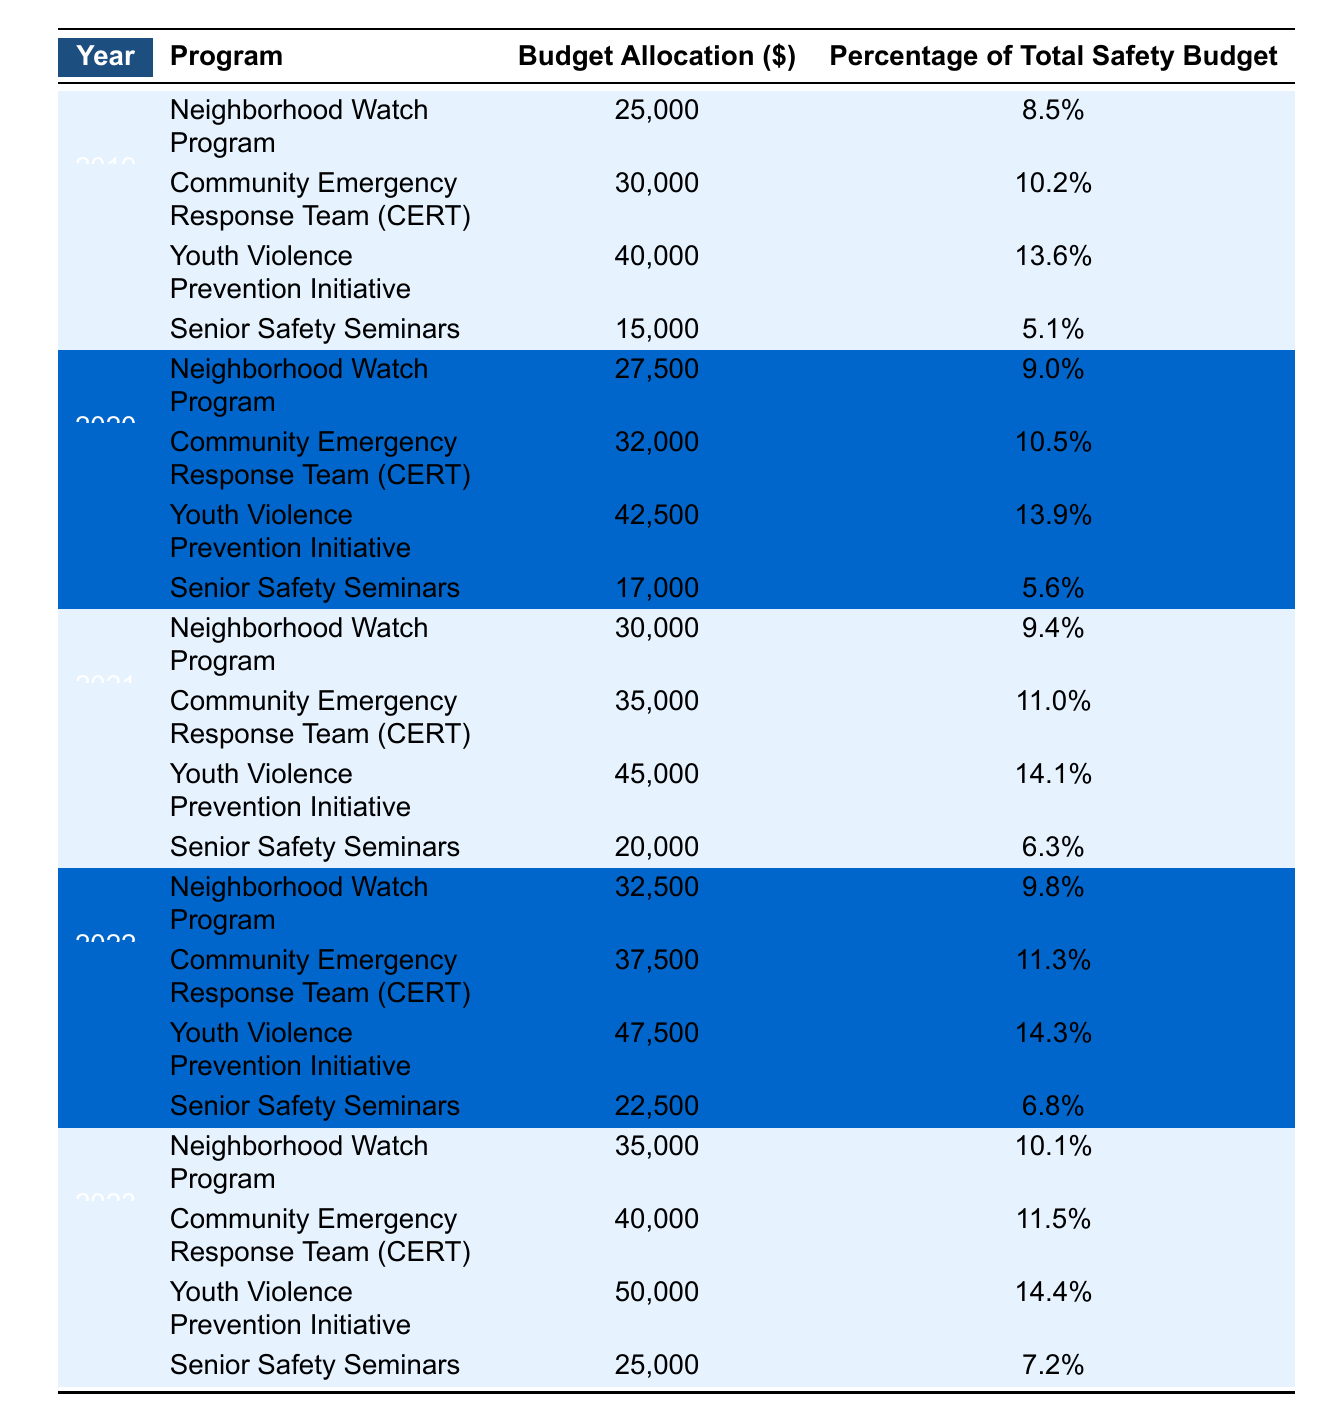What was the budget allocation for the Youth Violence Prevention Initiative in 2021? In the table, under the year 2021, the Youth Violence Prevention Initiative has a budget allocation of $45,000.
Answer: $45,000 What percentage of the total safety budget was allocated to the Senior Safety Seminars in 2022? The table shows that in 2022, the Senior Safety Seminars received a budget allocation of $22,500, which corresponds to 6.8% of the total safety budget.
Answer: 6.8% Which program saw the highest budget allocation in 2023? Looking at the 2023 row of the table, the Youth Violence Prevention Initiative had the highest budget allocation at $50,000.
Answer: Youth Violence Prevention Initiative What was the average budget allocation for the Neighborhood Watch Program from 2019 to 2023? To find the average, sum the budget allocations for the Neighborhood Watch Program: $25,000 + $27,500 + $30,000 + $32,500 + $35,000 = $150,000. Then divide by the 5 years: $150,000 / 5 = $30,000.
Answer: $30,000 Which program had the lowest budget allocation in 2019 and is it still the lowest in 2023? In 2019, the program with the lowest budget allocation was the Senior Safety Seminars with $15,000. In 2023, the Senior Safety Seminars had a budget of $25,000, which is still the lowest compared to the other programs for that year.
Answer: Yes What is the total budget allocated to the Community Emergency Response Team (CERT) from 2019 to 2023? Summing the allocations for CERT from the table: $30,000 (2019) + $32,000 (2020) + $35,000 (2021) + $37,500 (2022) + $40,000 (2023) gives a total of $174,500.
Answer: $174,500 Did the budget allocation for the Senior Safety Seminars increase from 2019 to 2023? In 2019, the allocation was $15,000, and in 2023, it increased to $25,000, indicating a rise in budget allocation over the years.
Answer: Yes What will be the total budget allocation for all programs in 2020? By adding all program allocations for 2020: $27,500 (Neighborhood Watch) + $32,000 (CERT) + $42,500 (Youth Violence Prevention Initiative) + $17,000 (Senior Safety Seminars) = $119,000.
Answer: $119,000 Which program was consistently allocated more than 10% of the total safety budget throughout 2019 to 2023? Checking the percentages for all programs over the years, the Youth Violence Prevention Initiative was consistently over 10% of the safety budget, with percentages of 13.6%, 13.9%, 14.1%, 14.3%, and 14.4%.
Answer: Youth Violence Prevention Initiative 